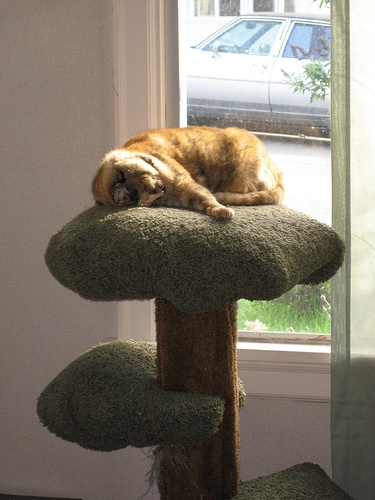Describe the objects in this image and their specific colors. I can see car in gray, white, darkgray, and lightblue tones and cat in gray, maroon, and tan tones in this image. 